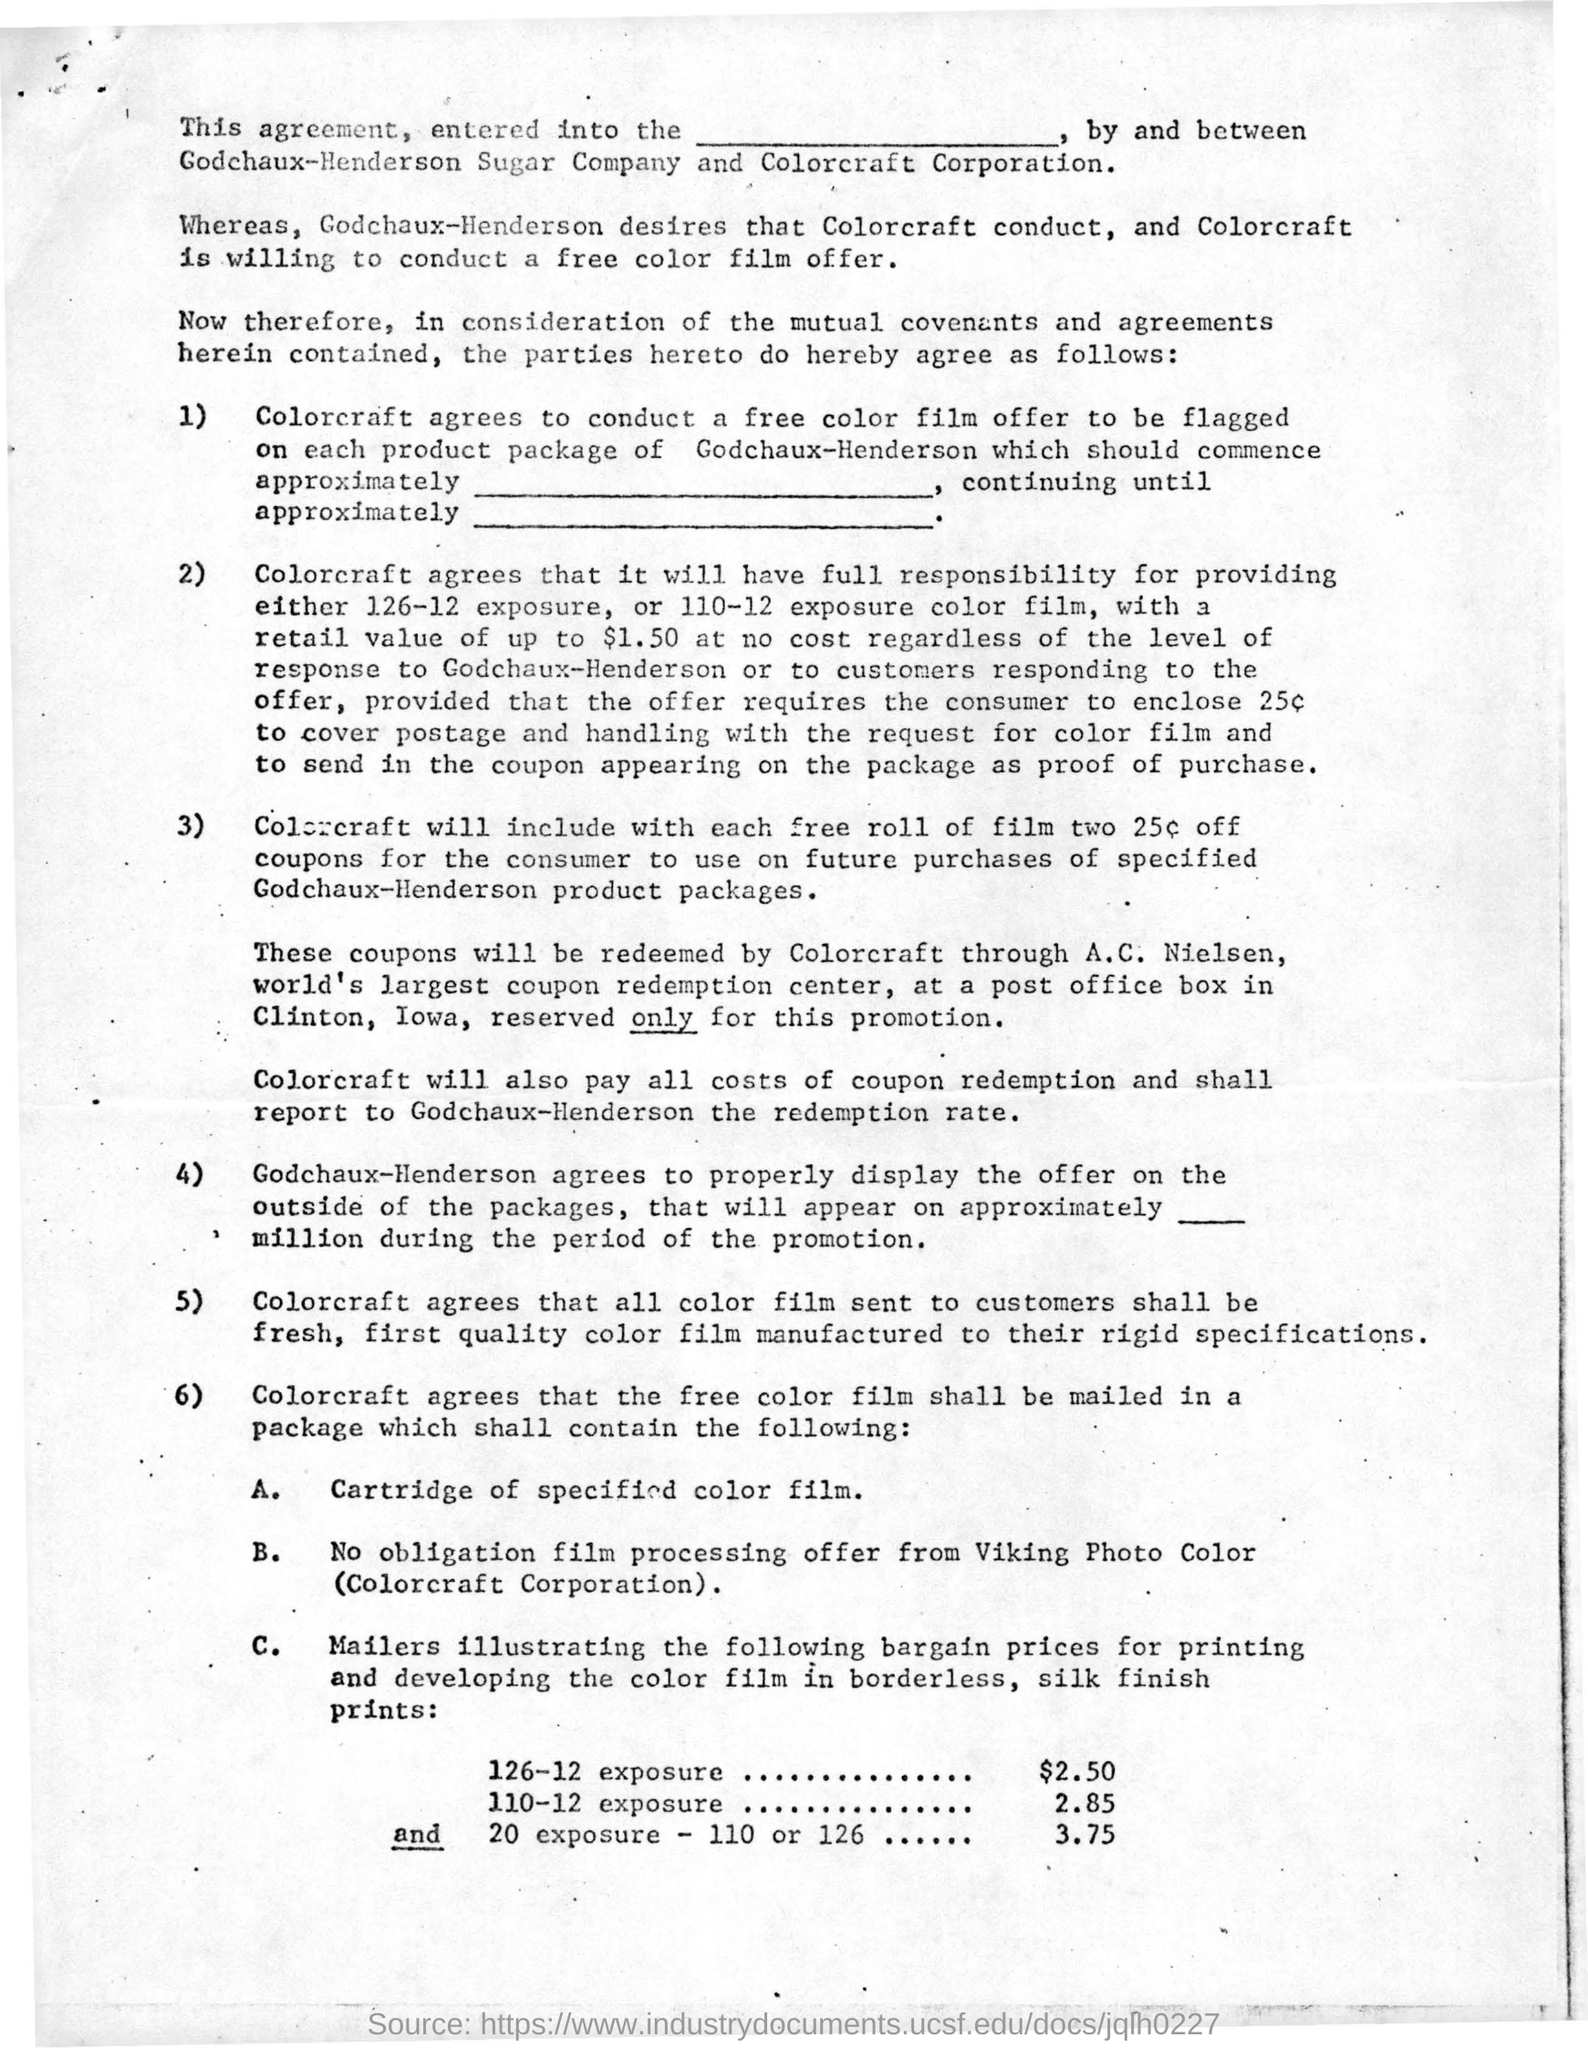Outline some significant characteristics in this image. Colorcraft will redeem its coupons through A.C. Nielsen, the world's largest coupon redemption center. 